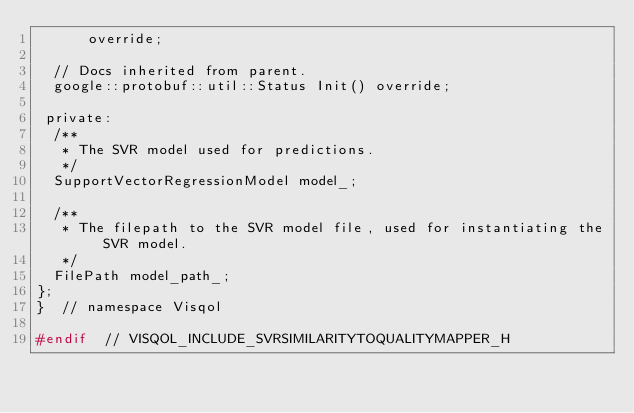Convert code to text. <code><loc_0><loc_0><loc_500><loc_500><_C_>      override;

  // Docs inherited from parent.
  google::protobuf::util::Status Init() override;

 private:
  /**
   * The SVR model used for predictions.
   */
  SupportVectorRegressionModel model_;

  /**
   * The filepath to the SVR model file, used for instantiating the SVR model.
   */
  FilePath model_path_;
};
}  // namespace Visqol

#endif  // VISQOL_INCLUDE_SVRSIMILARITYTOQUALITYMAPPER_H
</code> 